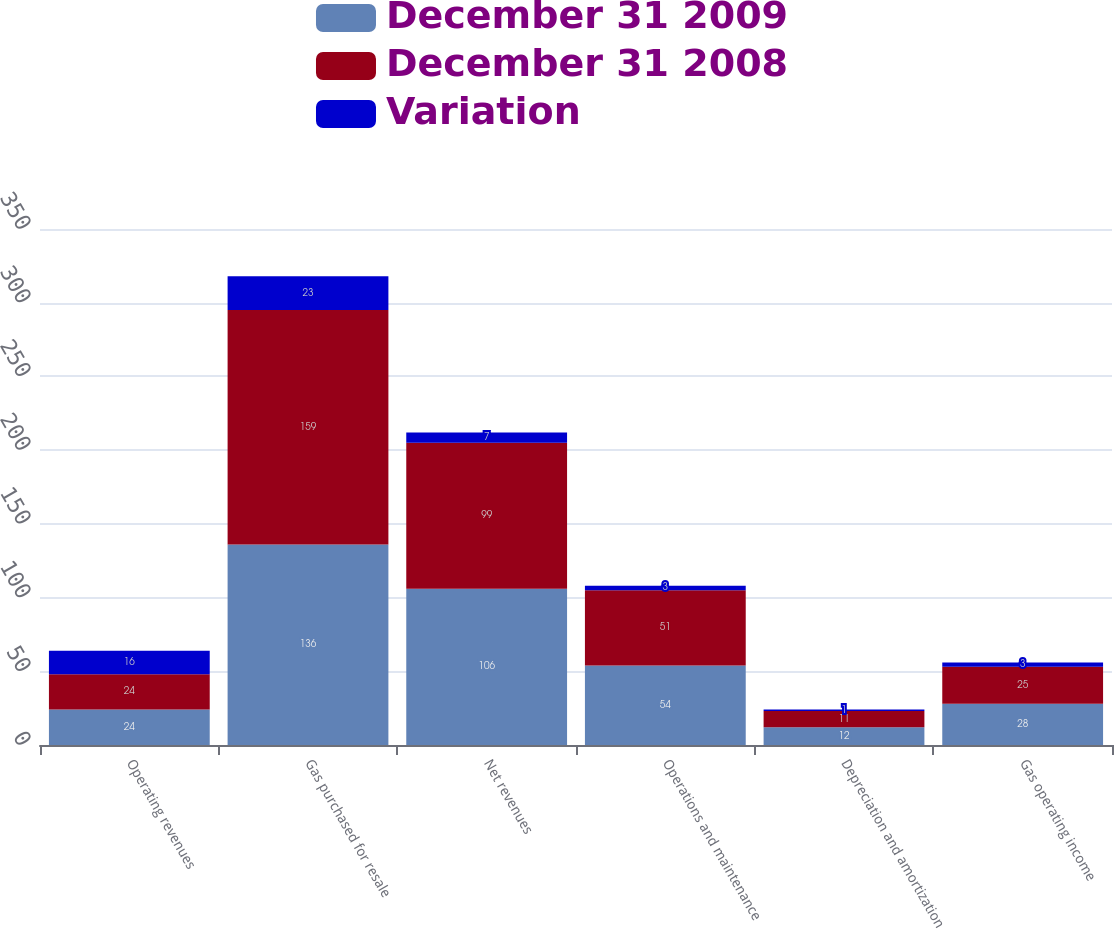Convert chart. <chart><loc_0><loc_0><loc_500><loc_500><stacked_bar_chart><ecel><fcel>Operating revenues<fcel>Gas purchased for resale<fcel>Net revenues<fcel>Operations and maintenance<fcel>Depreciation and amortization<fcel>Gas operating income<nl><fcel>December 31 2009<fcel>24<fcel>136<fcel>106<fcel>54<fcel>12<fcel>28<nl><fcel>December 31 2008<fcel>24<fcel>159<fcel>99<fcel>51<fcel>11<fcel>25<nl><fcel>Variation<fcel>16<fcel>23<fcel>7<fcel>3<fcel>1<fcel>3<nl></chart> 